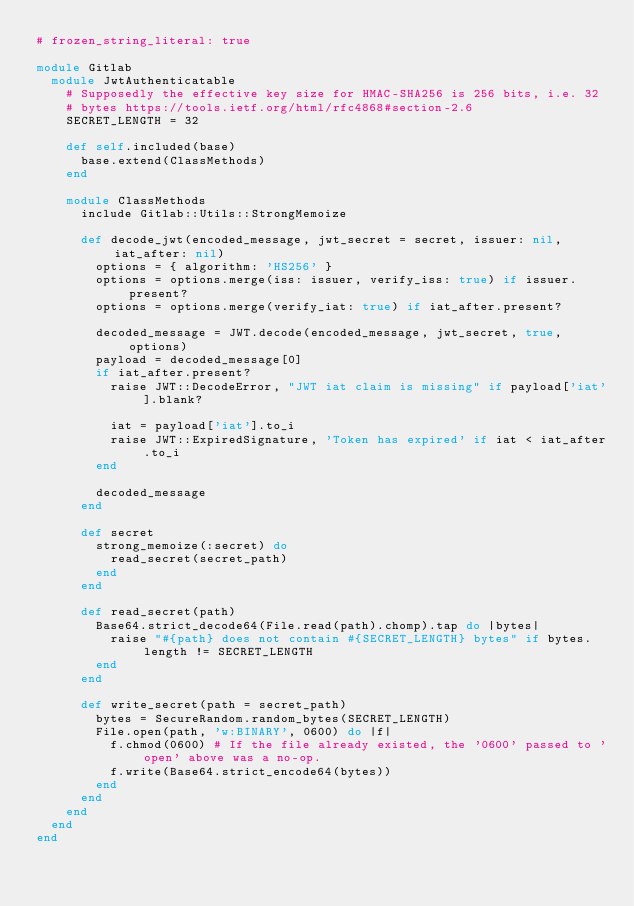<code> <loc_0><loc_0><loc_500><loc_500><_Ruby_># frozen_string_literal: true

module Gitlab
  module JwtAuthenticatable
    # Supposedly the effective key size for HMAC-SHA256 is 256 bits, i.e. 32
    # bytes https://tools.ietf.org/html/rfc4868#section-2.6
    SECRET_LENGTH = 32

    def self.included(base)
      base.extend(ClassMethods)
    end

    module ClassMethods
      include Gitlab::Utils::StrongMemoize

      def decode_jwt(encoded_message, jwt_secret = secret, issuer: nil, iat_after: nil)
        options = { algorithm: 'HS256' }
        options = options.merge(iss: issuer, verify_iss: true) if issuer.present?
        options = options.merge(verify_iat: true) if iat_after.present?

        decoded_message = JWT.decode(encoded_message, jwt_secret, true, options)
        payload = decoded_message[0]
        if iat_after.present?
          raise JWT::DecodeError, "JWT iat claim is missing" if payload['iat'].blank?

          iat = payload['iat'].to_i
          raise JWT::ExpiredSignature, 'Token has expired' if iat < iat_after.to_i
        end

        decoded_message
      end

      def secret
        strong_memoize(:secret) do
          read_secret(secret_path)
        end
      end

      def read_secret(path)
        Base64.strict_decode64(File.read(path).chomp).tap do |bytes|
          raise "#{path} does not contain #{SECRET_LENGTH} bytes" if bytes.length != SECRET_LENGTH
        end
      end

      def write_secret(path = secret_path)
        bytes = SecureRandom.random_bytes(SECRET_LENGTH)
        File.open(path, 'w:BINARY', 0600) do |f|
          f.chmod(0600) # If the file already existed, the '0600' passed to 'open' above was a no-op.
          f.write(Base64.strict_encode64(bytes))
        end
      end
    end
  end
end
</code> 